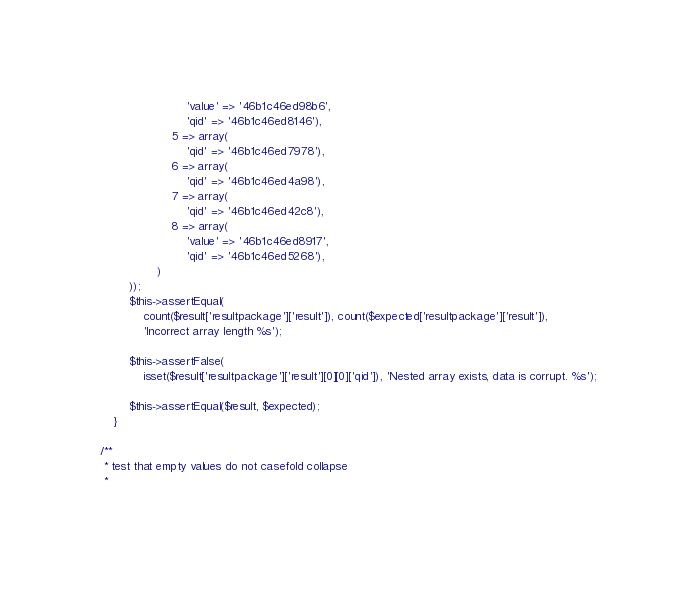<code> <loc_0><loc_0><loc_500><loc_500><_PHP_>						'value' => '46b1c46ed98b6',
						'qid' => '46b1c46ed8146'),
					5 => array(
						'qid' => '46b1c46ed7978'),
					6 => array(
						'qid' => '46b1c46ed4a98'),
					7 => array(
						'qid' => '46b1c46ed42c8'),
					8 => array(
						'value' => '46b1c46ed8917',
						'qid' => '46b1c46ed5268'),
				)
		));
		$this->assertEqual(
			count($result['resultpackage']['result']), count($expected['resultpackage']['result']),
			'Incorrect array length %s');

		$this->assertFalse(
			isset($result['resultpackage']['result'][0][0]['qid']), 'Nested array exists, data is corrupt. %s');

		$this->assertEqual($result, $expected);
	}

/**
 * test that empty values do not casefold collapse
 *</code> 